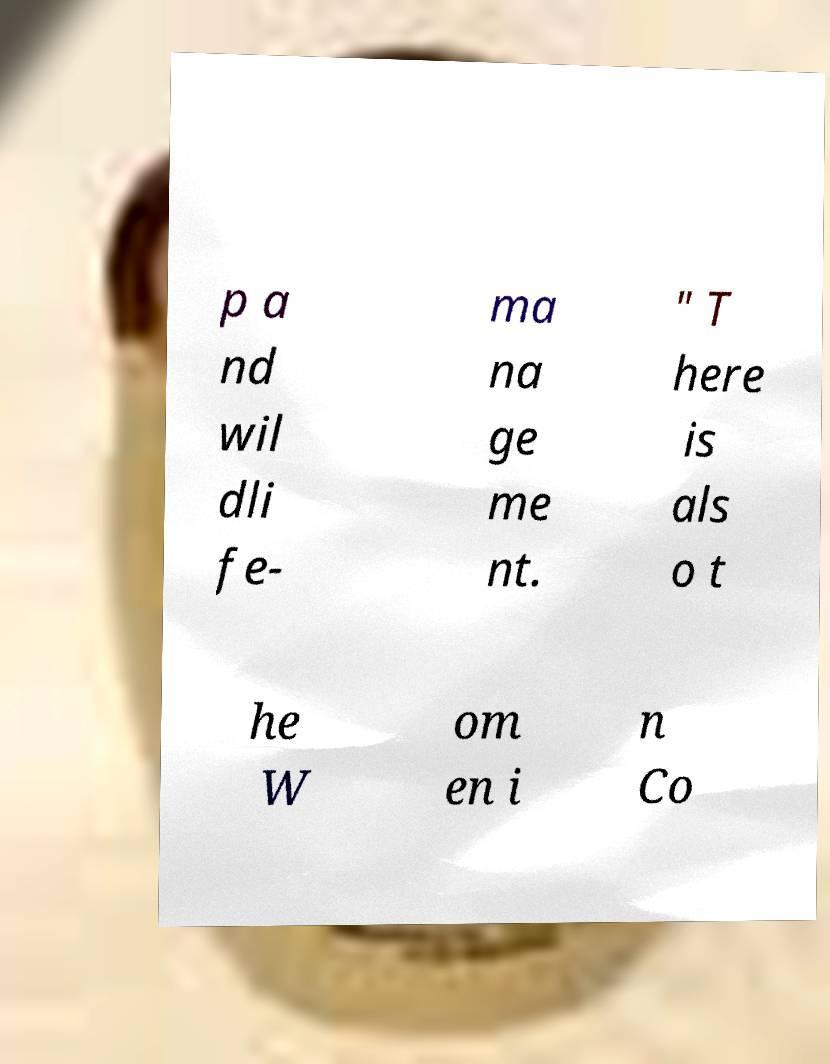I need the written content from this picture converted into text. Can you do that? p a nd wil dli fe- ma na ge me nt. " T here is als o t he W om en i n Co 